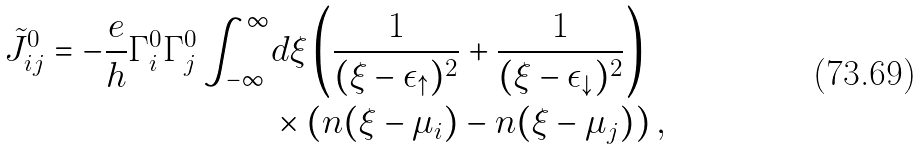Convert formula to latex. <formula><loc_0><loc_0><loc_500><loc_500>\tilde { J } _ { i j } ^ { 0 } = - \frac { e } { h } \Gamma ^ { 0 } _ { i } \Gamma ^ { 0 } _ { j } \int ^ { \infty } _ { - \infty } & d \xi \left ( \frac { 1 } { ( \xi - \epsilon _ { \uparrow } ) ^ { 2 } } + \frac { 1 } { ( \xi - \epsilon _ { \downarrow } ) ^ { 2 } } \right ) \\ & \times \left ( n ( \xi - \mu _ { i } ) - n ( \xi - \mu _ { j } ) \right ) ,</formula> 